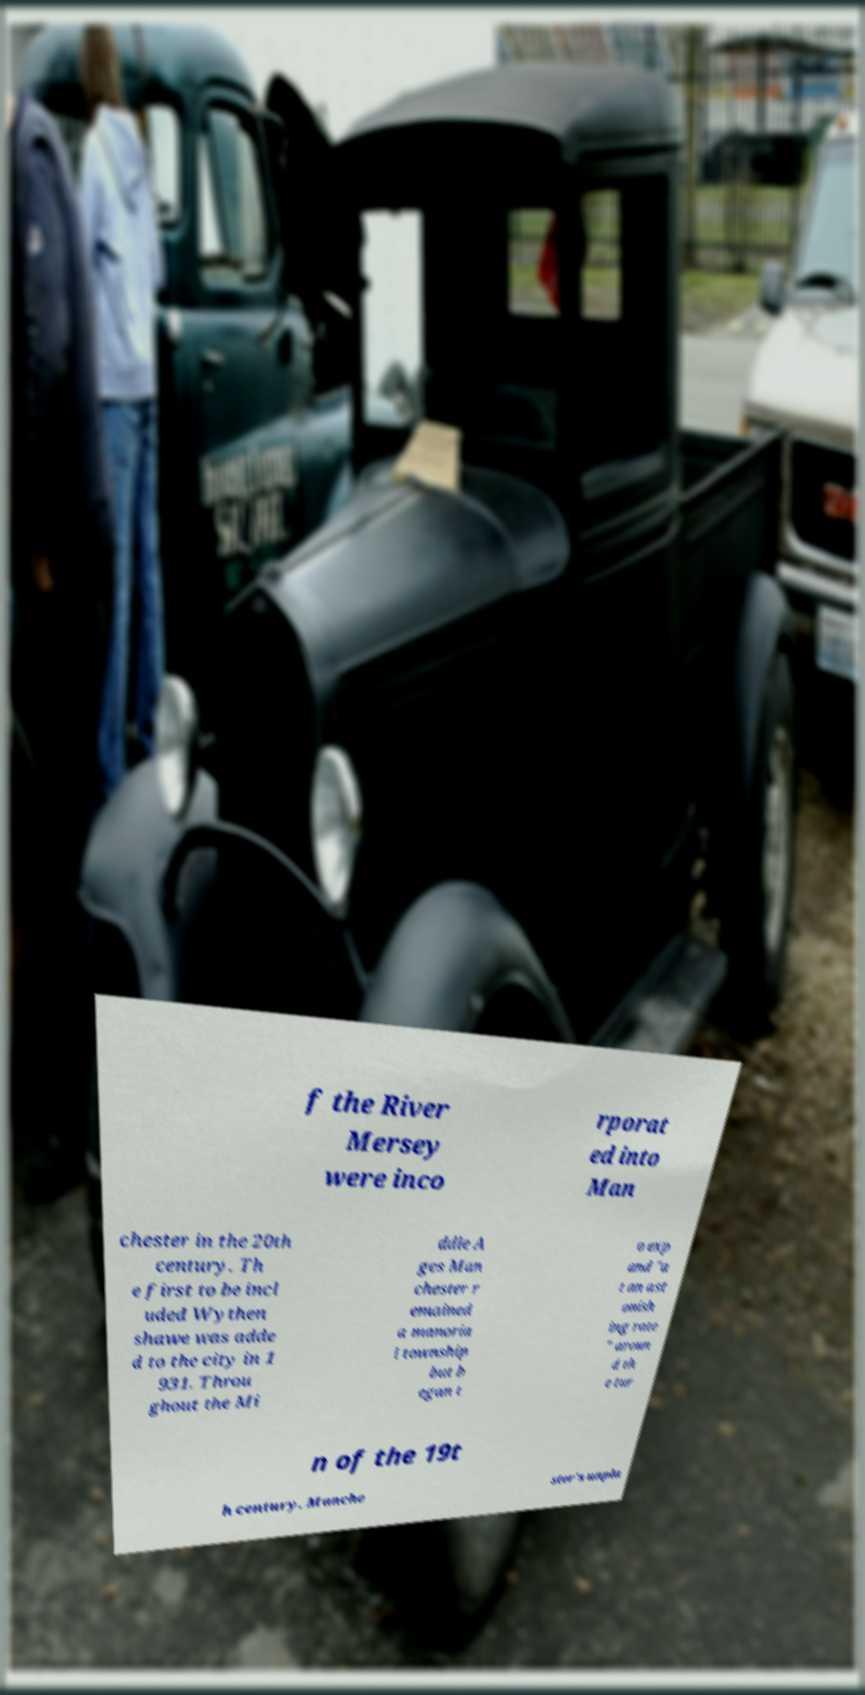Can you accurately transcribe the text from the provided image for me? f the River Mersey were inco rporat ed into Man chester in the 20th century. Th e first to be incl uded Wythen shawe was adde d to the city in 1 931. Throu ghout the Mi ddle A ges Man chester r emained a manoria l township but b egan t o exp and "a t an ast onish ing rate " aroun d th e tur n of the 19t h century. Manche ster's unpla 